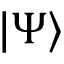Convert formula to latex. <formula><loc_0><loc_0><loc_500><loc_500>| \Psi \rangle</formula> 